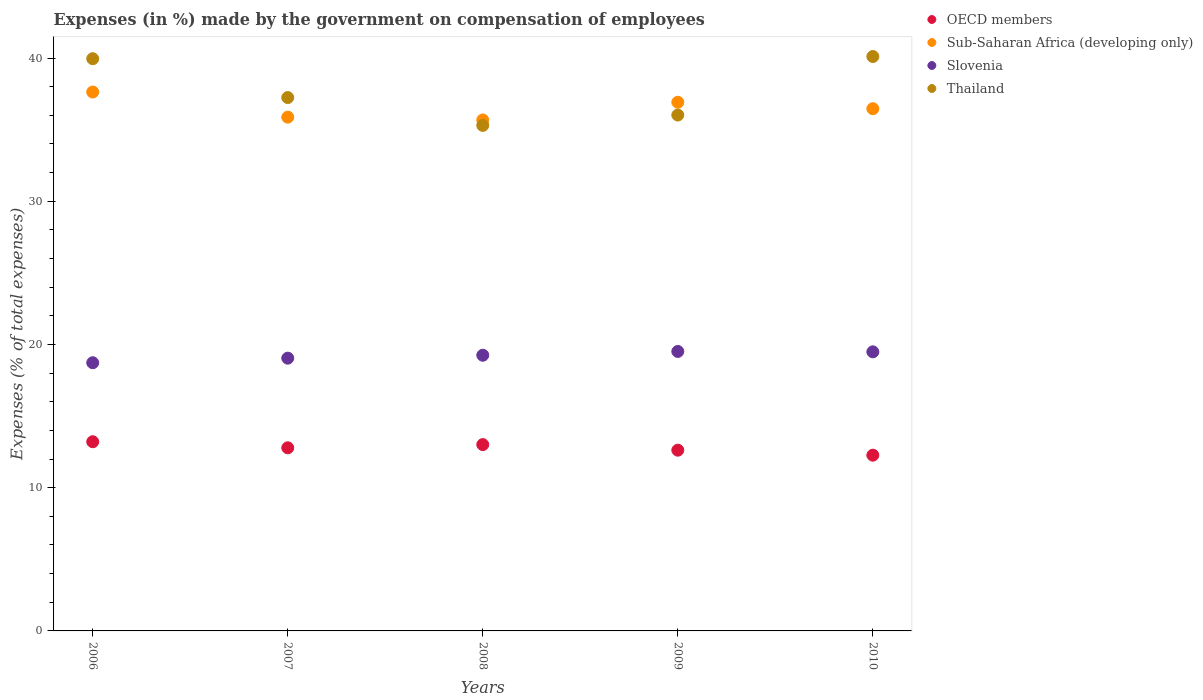Is the number of dotlines equal to the number of legend labels?
Make the answer very short. Yes. What is the percentage of expenses made by the government on compensation of employees in Sub-Saharan Africa (developing only) in 2006?
Give a very brief answer. 37.63. Across all years, what is the maximum percentage of expenses made by the government on compensation of employees in Thailand?
Your answer should be very brief. 40.11. Across all years, what is the minimum percentage of expenses made by the government on compensation of employees in Slovenia?
Give a very brief answer. 18.73. What is the total percentage of expenses made by the government on compensation of employees in OECD members in the graph?
Keep it short and to the point. 63.9. What is the difference between the percentage of expenses made by the government on compensation of employees in Sub-Saharan Africa (developing only) in 2006 and that in 2008?
Ensure brevity in your answer.  1.95. What is the difference between the percentage of expenses made by the government on compensation of employees in OECD members in 2007 and the percentage of expenses made by the government on compensation of employees in Sub-Saharan Africa (developing only) in 2009?
Offer a terse response. -24.13. What is the average percentage of expenses made by the government on compensation of employees in Thailand per year?
Your answer should be very brief. 37.72. In the year 2008, what is the difference between the percentage of expenses made by the government on compensation of employees in Sub-Saharan Africa (developing only) and percentage of expenses made by the government on compensation of employees in OECD members?
Give a very brief answer. 22.67. In how many years, is the percentage of expenses made by the government on compensation of employees in Thailand greater than 26 %?
Offer a very short reply. 5. What is the ratio of the percentage of expenses made by the government on compensation of employees in Slovenia in 2006 to that in 2008?
Your answer should be very brief. 0.97. Is the percentage of expenses made by the government on compensation of employees in Sub-Saharan Africa (developing only) in 2008 less than that in 2010?
Provide a short and direct response. Yes. Is the difference between the percentage of expenses made by the government on compensation of employees in Sub-Saharan Africa (developing only) in 2006 and 2010 greater than the difference between the percentage of expenses made by the government on compensation of employees in OECD members in 2006 and 2010?
Offer a terse response. Yes. What is the difference between the highest and the second highest percentage of expenses made by the government on compensation of employees in Thailand?
Offer a terse response. 0.15. What is the difference between the highest and the lowest percentage of expenses made by the government on compensation of employees in Sub-Saharan Africa (developing only)?
Offer a terse response. 1.95. In how many years, is the percentage of expenses made by the government on compensation of employees in Thailand greater than the average percentage of expenses made by the government on compensation of employees in Thailand taken over all years?
Provide a short and direct response. 2. Is it the case that in every year, the sum of the percentage of expenses made by the government on compensation of employees in Slovenia and percentage of expenses made by the government on compensation of employees in Sub-Saharan Africa (developing only)  is greater than the sum of percentage of expenses made by the government on compensation of employees in Thailand and percentage of expenses made by the government on compensation of employees in OECD members?
Keep it short and to the point. Yes. Is it the case that in every year, the sum of the percentage of expenses made by the government on compensation of employees in Sub-Saharan Africa (developing only) and percentage of expenses made by the government on compensation of employees in OECD members  is greater than the percentage of expenses made by the government on compensation of employees in Thailand?
Your response must be concise. Yes. Does the percentage of expenses made by the government on compensation of employees in OECD members monotonically increase over the years?
Your answer should be compact. No. Is the percentage of expenses made by the government on compensation of employees in Slovenia strictly less than the percentage of expenses made by the government on compensation of employees in Sub-Saharan Africa (developing only) over the years?
Your answer should be very brief. Yes. Are the values on the major ticks of Y-axis written in scientific E-notation?
Provide a short and direct response. No. Does the graph contain any zero values?
Your answer should be very brief. No. Where does the legend appear in the graph?
Provide a short and direct response. Top right. How many legend labels are there?
Give a very brief answer. 4. How are the legend labels stacked?
Give a very brief answer. Vertical. What is the title of the graph?
Your answer should be very brief. Expenses (in %) made by the government on compensation of employees. Does "Syrian Arab Republic" appear as one of the legend labels in the graph?
Your answer should be very brief. No. What is the label or title of the Y-axis?
Ensure brevity in your answer.  Expenses (% of total expenses). What is the Expenses (% of total expenses) of OECD members in 2006?
Provide a succinct answer. 13.21. What is the Expenses (% of total expenses) in Sub-Saharan Africa (developing only) in 2006?
Your answer should be compact. 37.63. What is the Expenses (% of total expenses) of Slovenia in 2006?
Provide a succinct answer. 18.73. What is the Expenses (% of total expenses) in Thailand in 2006?
Make the answer very short. 39.95. What is the Expenses (% of total expenses) in OECD members in 2007?
Offer a terse response. 12.79. What is the Expenses (% of total expenses) in Sub-Saharan Africa (developing only) in 2007?
Give a very brief answer. 35.87. What is the Expenses (% of total expenses) of Slovenia in 2007?
Keep it short and to the point. 19.05. What is the Expenses (% of total expenses) of Thailand in 2007?
Make the answer very short. 37.24. What is the Expenses (% of total expenses) of OECD members in 2008?
Make the answer very short. 13.01. What is the Expenses (% of total expenses) in Sub-Saharan Africa (developing only) in 2008?
Your response must be concise. 35.68. What is the Expenses (% of total expenses) in Slovenia in 2008?
Your answer should be very brief. 19.25. What is the Expenses (% of total expenses) in Thailand in 2008?
Your answer should be compact. 35.3. What is the Expenses (% of total expenses) in OECD members in 2009?
Ensure brevity in your answer.  12.62. What is the Expenses (% of total expenses) in Sub-Saharan Africa (developing only) in 2009?
Offer a very short reply. 36.91. What is the Expenses (% of total expenses) of Slovenia in 2009?
Make the answer very short. 19.51. What is the Expenses (% of total expenses) in Thailand in 2009?
Your answer should be very brief. 36.02. What is the Expenses (% of total expenses) of OECD members in 2010?
Provide a succinct answer. 12.27. What is the Expenses (% of total expenses) of Sub-Saharan Africa (developing only) in 2010?
Ensure brevity in your answer.  36.46. What is the Expenses (% of total expenses) of Slovenia in 2010?
Ensure brevity in your answer.  19.49. What is the Expenses (% of total expenses) in Thailand in 2010?
Make the answer very short. 40.11. Across all years, what is the maximum Expenses (% of total expenses) in OECD members?
Offer a very short reply. 13.21. Across all years, what is the maximum Expenses (% of total expenses) of Sub-Saharan Africa (developing only)?
Your answer should be compact. 37.63. Across all years, what is the maximum Expenses (% of total expenses) in Slovenia?
Make the answer very short. 19.51. Across all years, what is the maximum Expenses (% of total expenses) in Thailand?
Your answer should be very brief. 40.11. Across all years, what is the minimum Expenses (% of total expenses) of OECD members?
Your answer should be compact. 12.27. Across all years, what is the minimum Expenses (% of total expenses) in Sub-Saharan Africa (developing only)?
Ensure brevity in your answer.  35.68. Across all years, what is the minimum Expenses (% of total expenses) in Slovenia?
Offer a terse response. 18.73. Across all years, what is the minimum Expenses (% of total expenses) of Thailand?
Give a very brief answer. 35.3. What is the total Expenses (% of total expenses) in OECD members in the graph?
Offer a terse response. 63.9. What is the total Expenses (% of total expenses) of Sub-Saharan Africa (developing only) in the graph?
Offer a terse response. 182.56. What is the total Expenses (% of total expenses) of Slovenia in the graph?
Keep it short and to the point. 96.02. What is the total Expenses (% of total expenses) of Thailand in the graph?
Your response must be concise. 188.62. What is the difference between the Expenses (% of total expenses) in OECD members in 2006 and that in 2007?
Your response must be concise. 0.42. What is the difference between the Expenses (% of total expenses) of Sub-Saharan Africa (developing only) in 2006 and that in 2007?
Your answer should be compact. 1.75. What is the difference between the Expenses (% of total expenses) in Slovenia in 2006 and that in 2007?
Your answer should be compact. -0.32. What is the difference between the Expenses (% of total expenses) of Thailand in 2006 and that in 2007?
Give a very brief answer. 2.71. What is the difference between the Expenses (% of total expenses) in OECD members in 2006 and that in 2008?
Give a very brief answer. 0.2. What is the difference between the Expenses (% of total expenses) of Sub-Saharan Africa (developing only) in 2006 and that in 2008?
Offer a very short reply. 1.95. What is the difference between the Expenses (% of total expenses) in Slovenia in 2006 and that in 2008?
Offer a very short reply. -0.52. What is the difference between the Expenses (% of total expenses) of Thailand in 2006 and that in 2008?
Provide a succinct answer. 4.66. What is the difference between the Expenses (% of total expenses) of OECD members in 2006 and that in 2009?
Keep it short and to the point. 0.59. What is the difference between the Expenses (% of total expenses) in Sub-Saharan Africa (developing only) in 2006 and that in 2009?
Provide a succinct answer. 0.71. What is the difference between the Expenses (% of total expenses) in Slovenia in 2006 and that in 2009?
Ensure brevity in your answer.  -0.79. What is the difference between the Expenses (% of total expenses) in Thailand in 2006 and that in 2009?
Your answer should be very brief. 3.93. What is the difference between the Expenses (% of total expenses) of OECD members in 2006 and that in 2010?
Offer a very short reply. 0.94. What is the difference between the Expenses (% of total expenses) of Sub-Saharan Africa (developing only) in 2006 and that in 2010?
Provide a short and direct response. 1.16. What is the difference between the Expenses (% of total expenses) in Slovenia in 2006 and that in 2010?
Provide a succinct answer. -0.76. What is the difference between the Expenses (% of total expenses) of Thailand in 2006 and that in 2010?
Your response must be concise. -0.15. What is the difference between the Expenses (% of total expenses) in OECD members in 2007 and that in 2008?
Keep it short and to the point. -0.22. What is the difference between the Expenses (% of total expenses) in Sub-Saharan Africa (developing only) in 2007 and that in 2008?
Keep it short and to the point. 0.2. What is the difference between the Expenses (% of total expenses) in Slovenia in 2007 and that in 2008?
Your answer should be compact. -0.2. What is the difference between the Expenses (% of total expenses) in Thailand in 2007 and that in 2008?
Give a very brief answer. 1.94. What is the difference between the Expenses (% of total expenses) of OECD members in 2007 and that in 2009?
Provide a short and direct response. 0.17. What is the difference between the Expenses (% of total expenses) in Sub-Saharan Africa (developing only) in 2007 and that in 2009?
Keep it short and to the point. -1.04. What is the difference between the Expenses (% of total expenses) in Slovenia in 2007 and that in 2009?
Offer a terse response. -0.47. What is the difference between the Expenses (% of total expenses) in Thailand in 2007 and that in 2009?
Your answer should be very brief. 1.22. What is the difference between the Expenses (% of total expenses) of OECD members in 2007 and that in 2010?
Make the answer very short. 0.52. What is the difference between the Expenses (% of total expenses) in Sub-Saharan Africa (developing only) in 2007 and that in 2010?
Keep it short and to the point. -0.59. What is the difference between the Expenses (% of total expenses) of Slovenia in 2007 and that in 2010?
Your answer should be very brief. -0.44. What is the difference between the Expenses (% of total expenses) in Thailand in 2007 and that in 2010?
Make the answer very short. -2.87. What is the difference between the Expenses (% of total expenses) of OECD members in 2008 and that in 2009?
Offer a terse response. 0.39. What is the difference between the Expenses (% of total expenses) in Sub-Saharan Africa (developing only) in 2008 and that in 2009?
Give a very brief answer. -1.24. What is the difference between the Expenses (% of total expenses) in Slovenia in 2008 and that in 2009?
Your response must be concise. -0.26. What is the difference between the Expenses (% of total expenses) of Thailand in 2008 and that in 2009?
Your answer should be very brief. -0.72. What is the difference between the Expenses (% of total expenses) in OECD members in 2008 and that in 2010?
Offer a very short reply. 0.74. What is the difference between the Expenses (% of total expenses) of Sub-Saharan Africa (developing only) in 2008 and that in 2010?
Your answer should be compact. -0.79. What is the difference between the Expenses (% of total expenses) in Slovenia in 2008 and that in 2010?
Your response must be concise. -0.24. What is the difference between the Expenses (% of total expenses) in Thailand in 2008 and that in 2010?
Keep it short and to the point. -4.81. What is the difference between the Expenses (% of total expenses) of OECD members in 2009 and that in 2010?
Provide a succinct answer. 0.35. What is the difference between the Expenses (% of total expenses) of Sub-Saharan Africa (developing only) in 2009 and that in 2010?
Keep it short and to the point. 0.45. What is the difference between the Expenses (% of total expenses) in Slovenia in 2009 and that in 2010?
Ensure brevity in your answer.  0.03. What is the difference between the Expenses (% of total expenses) in Thailand in 2009 and that in 2010?
Ensure brevity in your answer.  -4.09. What is the difference between the Expenses (% of total expenses) in OECD members in 2006 and the Expenses (% of total expenses) in Sub-Saharan Africa (developing only) in 2007?
Keep it short and to the point. -22.66. What is the difference between the Expenses (% of total expenses) in OECD members in 2006 and the Expenses (% of total expenses) in Slovenia in 2007?
Give a very brief answer. -5.84. What is the difference between the Expenses (% of total expenses) of OECD members in 2006 and the Expenses (% of total expenses) of Thailand in 2007?
Keep it short and to the point. -24.03. What is the difference between the Expenses (% of total expenses) in Sub-Saharan Africa (developing only) in 2006 and the Expenses (% of total expenses) in Slovenia in 2007?
Your answer should be very brief. 18.58. What is the difference between the Expenses (% of total expenses) of Sub-Saharan Africa (developing only) in 2006 and the Expenses (% of total expenses) of Thailand in 2007?
Offer a terse response. 0.39. What is the difference between the Expenses (% of total expenses) of Slovenia in 2006 and the Expenses (% of total expenses) of Thailand in 2007?
Keep it short and to the point. -18.52. What is the difference between the Expenses (% of total expenses) in OECD members in 2006 and the Expenses (% of total expenses) in Sub-Saharan Africa (developing only) in 2008?
Offer a terse response. -22.47. What is the difference between the Expenses (% of total expenses) of OECD members in 2006 and the Expenses (% of total expenses) of Slovenia in 2008?
Give a very brief answer. -6.04. What is the difference between the Expenses (% of total expenses) in OECD members in 2006 and the Expenses (% of total expenses) in Thailand in 2008?
Provide a succinct answer. -22.09. What is the difference between the Expenses (% of total expenses) of Sub-Saharan Africa (developing only) in 2006 and the Expenses (% of total expenses) of Slovenia in 2008?
Provide a short and direct response. 18.38. What is the difference between the Expenses (% of total expenses) of Sub-Saharan Africa (developing only) in 2006 and the Expenses (% of total expenses) of Thailand in 2008?
Your response must be concise. 2.33. What is the difference between the Expenses (% of total expenses) in Slovenia in 2006 and the Expenses (% of total expenses) in Thailand in 2008?
Provide a succinct answer. -16.57. What is the difference between the Expenses (% of total expenses) of OECD members in 2006 and the Expenses (% of total expenses) of Sub-Saharan Africa (developing only) in 2009?
Provide a succinct answer. -23.71. What is the difference between the Expenses (% of total expenses) of OECD members in 2006 and the Expenses (% of total expenses) of Slovenia in 2009?
Offer a terse response. -6.31. What is the difference between the Expenses (% of total expenses) of OECD members in 2006 and the Expenses (% of total expenses) of Thailand in 2009?
Give a very brief answer. -22.81. What is the difference between the Expenses (% of total expenses) in Sub-Saharan Africa (developing only) in 2006 and the Expenses (% of total expenses) in Slovenia in 2009?
Ensure brevity in your answer.  18.11. What is the difference between the Expenses (% of total expenses) of Sub-Saharan Africa (developing only) in 2006 and the Expenses (% of total expenses) of Thailand in 2009?
Provide a short and direct response. 1.61. What is the difference between the Expenses (% of total expenses) in Slovenia in 2006 and the Expenses (% of total expenses) in Thailand in 2009?
Offer a terse response. -17.29. What is the difference between the Expenses (% of total expenses) in OECD members in 2006 and the Expenses (% of total expenses) in Sub-Saharan Africa (developing only) in 2010?
Ensure brevity in your answer.  -23.26. What is the difference between the Expenses (% of total expenses) of OECD members in 2006 and the Expenses (% of total expenses) of Slovenia in 2010?
Provide a succinct answer. -6.28. What is the difference between the Expenses (% of total expenses) of OECD members in 2006 and the Expenses (% of total expenses) of Thailand in 2010?
Make the answer very short. -26.9. What is the difference between the Expenses (% of total expenses) of Sub-Saharan Africa (developing only) in 2006 and the Expenses (% of total expenses) of Slovenia in 2010?
Your answer should be very brief. 18.14. What is the difference between the Expenses (% of total expenses) in Sub-Saharan Africa (developing only) in 2006 and the Expenses (% of total expenses) in Thailand in 2010?
Your response must be concise. -2.48. What is the difference between the Expenses (% of total expenses) of Slovenia in 2006 and the Expenses (% of total expenses) of Thailand in 2010?
Offer a very short reply. -21.38. What is the difference between the Expenses (% of total expenses) in OECD members in 2007 and the Expenses (% of total expenses) in Sub-Saharan Africa (developing only) in 2008?
Provide a succinct answer. -22.89. What is the difference between the Expenses (% of total expenses) in OECD members in 2007 and the Expenses (% of total expenses) in Slovenia in 2008?
Ensure brevity in your answer.  -6.46. What is the difference between the Expenses (% of total expenses) of OECD members in 2007 and the Expenses (% of total expenses) of Thailand in 2008?
Provide a succinct answer. -22.51. What is the difference between the Expenses (% of total expenses) of Sub-Saharan Africa (developing only) in 2007 and the Expenses (% of total expenses) of Slovenia in 2008?
Keep it short and to the point. 16.62. What is the difference between the Expenses (% of total expenses) in Sub-Saharan Africa (developing only) in 2007 and the Expenses (% of total expenses) in Thailand in 2008?
Keep it short and to the point. 0.58. What is the difference between the Expenses (% of total expenses) in Slovenia in 2007 and the Expenses (% of total expenses) in Thailand in 2008?
Give a very brief answer. -16.25. What is the difference between the Expenses (% of total expenses) of OECD members in 2007 and the Expenses (% of total expenses) of Sub-Saharan Africa (developing only) in 2009?
Keep it short and to the point. -24.13. What is the difference between the Expenses (% of total expenses) in OECD members in 2007 and the Expenses (% of total expenses) in Slovenia in 2009?
Provide a succinct answer. -6.73. What is the difference between the Expenses (% of total expenses) in OECD members in 2007 and the Expenses (% of total expenses) in Thailand in 2009?
Offer a terse response. -23.23. What is the difference between the Expenses (% of total expenses) of Sub-Saharan Africa (developing only) in 2007 and the Expenses (% of total expenses) of Slovenia in 2009?
Offer a very short reply. 16.36. What is the difference between the Expenses (% of total expenses) of Sub-Saharan Africa (developing only) in 2007 and the Expenses (% of total expenses) of Thailand in 2009?
Offer a terse response. -0.15. What is the difference between the Expenses (% of total expenses) in Slovenia in 2007 and the Expenses (% of total expenses) in Thailand in 2009?
Your response must be concise. -16.98. What is the difference between the Expenses (% of total expenses) of OECD members in 2007 and the Expenses (% of total expenses) of Sub-Saharan Africa (developing only) in 2010?
Offer a terse response. -23.68. What is the difference between the Expenses (% of total expenses) of OECD members in 2007 and the Expenses (% of total expenses) of Slovenia in 2010?
Make the answer very short. -6.7. What is the difference between the Expenses (% of total expenses) of OECD members in 2007 and the Expenses (% of total expenses) of Thailand in 2010?
Provide a short and direct response. -27.32. What is the difference between the Expenses (% of total expenses) of Sub-Saharan Africa (developing only) in 2007 and the Expenses (% of total expenses) of Slovenia in 2010?
Your answer should be very brief. 16.39. What is the difference between the Expenses (% of total expenses) in Sub-Saharan Africa (developing only) in 2007 and the Expenses (% of total expenses) in Thailand in 2010?
Provide a succinct answer. -4.24. What is the difference between the Expenses (% of total expenses) of Slovenia in 2007 and the Expenses (% of total expenses) of Thailand in 2010?
Provide a succinct answer. -21.06. What is the difference between the Expenses (% of total expenses) in OECD members in 2008 and the Expenses (% of total expenses) in Sub-Saharan Africa (developing only) in 2009?
Make the answer very short. -23.9. What is the difference between the Expenses (% of total expenses) of OECD members in 2008 and the Expenses (% of total expenses) of Slovenia in 2009?
Your answer should be very brief. -6.5. What is the difference between the Expenses (% of total expenses) of OECD members in 2008 and the Expenses (% of total expenses) of Thailand in 2009?
Keep it short and to the point. -23.01. What is the difference between the Expenses (% of total expenses) of Sub-Saharan Africa (developing only) in 2008 and the Expenses (% of total expenses) of Slovenia in 2009?
Offer a very short reply. 16.16. What is the difference between the Expenses (% of total expenses) in Sub-Saharan Africa (developing only) in 2008 and the Expenses (% of total expenses) in Thailand in 2009?
Ensure brevity in your answer.  -0.34. What is the difference between the Expenses (% of total expenses) of Slovenia in 2008 and the Expenses (% of total expenses) of Thailand in 2009?
Provide a succinct answer. -16.77. What is the difference between the Expenses (% of total expenses) of OECD members in 2008 and the Expenses (% of total expenses) of Sub-Saharan Africa (developing only) in 2010?
Keep it short and to the point. -23.45. What is the difference between the Expenses (% of total expenses) of OECD members in 2008 and the Expenses (% of total expenses) of Slovenia in 2010?
Offer a terse response. -6.48. What is the difference between the Expenses (% of total expenses) in OECD members in 2008 and the Expenses (% of total expenses) in Thailand in 2010?
Your answer should be very brief. -27.1. What is the difference between the Expenses (% of total expenses) of Sub-Saharan Africa (developing only) in 2008 and the Expenses (% of total expenses) of Slovenia in 2010?
Keep it short and to the point. 16.19. What is the difference between the Expenses (% of total expenses) of Sub-Saharan Africa (developing only) in 2008 and the Expenses (% of total expenses) of Thailand in 2010?
Offer a very short reply. -4.43. What is the difference between the Expenses (% of total expenses) of Slovenia in 2008 and the Expenses (% of total expenses) of Thailand in 2010?
Keep it short and to the point. -20.86. What is the difference between the Expenses (% of total expenses) in OECD members in 2009 and the Expenses (% of total expenses) in Sub-Saharan Africa (developing only) in 2010?
Your answer should be very brief. -23.84. What is the difference between the Expenses (% of total expenses) in OECD members in 2009 and the Expenses (% of total expenses) in Slovenia in 2010?
Offer a terse response. -6.87. What is the difference between the Expenses (% of total expenses) of OECD members in 2009 and the Expenses (% of total expenses) of Thailand in 2010?
Your answer should be very brief. -27.49. What is the difference between the Expenses (% of total expenses) of Sub-Saharan Africa (developing only) in 2009 and the Expenses (% of total expenses) of Slovenia in 2010?
Ensure brevity in your answer.  17.43. What is the difference between the Expenses (% of total expenses) in Sub-Saharan Africa (developing only) in 2009 and the Expenses (% of total expenses) in Thailand in 2010?
Keep it short and to the point. -3.19. What is the difference between the Expenses (% of total expenses) in Slovenia in 2009 and the Expenses (% of total expenses) in Thailand in 2010?
Keep it short and to the point. -20.59. What is the average Expenses (% of total expenses) in OECD members per year?
Make the answer very short. 12.78. What is the average Expenses (% of total expenses) in Sub-Saharan Africa (developing only) per year?
Your answer should be very brief. 36.51. What is the average Expenses (% of total expenses) of Slovenia per year?
Ensure brevity in your answer.  19.2. What is the average Expenses (% of total expenses) of Thailand per year?
Keep it short and to the point. 37.72. In the year 2006, what is the difference between the Expenses (% of total expenses) of OECD members and Expenses (% of total expenses) of Sub-Saharan Africa (developing only)?
Offer a very short reply. -24.42. In the year 2006, what is the difference between the Expenses (% of total expenses) in OECD members and Expenses (% of total expenses) in Slovenia?
Ensure brevity in your answer.  -5.52. In the year 2006, what is the difference between the Expenses (% of total expenses) in OECD members and Expenses (% of total expenses) in Thailand?
Give a very brief answer. -26.75. In the year 2006, what is the difference between the Expenses (% of total expenses) of Sub-Saharan Africa (developing only) and Expenses (% of total expenses) of Slovenia?
Make the answer very short. 18.9. In the year 2006, what is the difference between the Expenses (% of total expenses) in Sub-Saharan Africa (developing only) and Expenses (% of total expenses) in Thailand?
Provide a succinct answer. -2.33. In the year 2006, what is the difference between the Expenses (% of total expenses) of Slovenia and Expenses (% of total expenses) of Thailand?
Keep it short and to the point. -21.23. In the year 2007, what is the difference between the Expenses (% of total expenses) in OECD members and Expenses (% of total expenses) in Sub-Saharan Africa (developing only)?
Your answer should be compact. -23.09. In the year 2007, what is the difference between the Expenses (% of total expenses) in OECD members and Expenses (% of total expenses) in Slovenia?
Provide a short and direct response. -6.26. In the year 2007, what is the difference between the Expenses (% of total expenses) of OECD members and Expenses (% of total expenses) of Thailand?
Give a very brief answer. -24.46. In the year 2007, what is the difference between the Expenses (% of total expenses) in Sub-Saharan Africa (developing only) and Expenses (% of total expenses) in Slovenia?
Your answer should be compact. 16.83. In the year 2007, what is the difference between the Expenses (% of total expenses) in Sub-Saharan Africa (developing only) and Expenses (% of total expenses) in Thailand?
Offer a terse response. -1.37. In the year 2007, what is the difference between the Expenses (% of total expenses) in Slovenia and Expenses (% of total expenses) in Thailand?
Make the answer very short. -18.2. In the year 2008, what is the difference between the Expenses (% of total expenses) in OECD members and Expenses (% of total expenses) in Sub-Saharan Africa (developing only)?
Your answer should be compact. -22.67. In the year 2008, what is the difference between the Expenses (% of total expenses) in OECD members and Expenses (% of total expenses) in Slovenia?
Make the answer very short. -6.24. In the year 2008, what is the difference between the Expenses (% of total expenses) in OECD members and Expenses (% of total expenses) in Thailand?
Your response must be concise. -22.29. In the year 2008, what is the difference between the Expenses (% of total expenses) in Sub-Saharan Africa (developing only) and Expenses (% of total expenses) in Slovenia?
Your response must be concise. 16.43. In the year 2008, what is the difference between the Expenses (% of total expenses) in Sub-Saharan Africa (developing only) and Expenses (% of total expenses) in Thailand?
Give a very brief answer. 0.38. In the year 2008, what is the difference between the Expenses (% of total expenses) in Slovenia and Expenses (% of total expenses) in Thailand?
Offer a very short reply. -16.05. In the year 2009, what is the difference between the Expenses (% of total expenses) of OECD members and Expenses (% of total expenses) of Sub-Saharan Africa (developing only)?
Your answer should be compact. -24.29. In the year 2009, what is the difference between the Expenses (% of total expenses) of OECD members and Expenses (% of total expenses) of Slovenia?
Provide a short and direct response. -6.89. In the year 2009, what is the difference between the Expenses (% of total expenses) of OECD members and Expenses (% of total expenses) of Thailand?
Keep it short and to the point. -23.4. In the year 2009, what is the difference between the Expenses (% of total expenses) in Sub-Saharan Africa (developing only) and Expenses (% of total expenses) in Slovenia?
Make the answer very short. 17.4. In the year 2009, what is the difference between the Expenses (% of total expenses) of Sub-Saharan Africa (developing only) and Expenses (% of total expenses) of Thailand?
Offer a very short reply. 0.89. In the year 2009, what is the difference between the Expenses (% of total expenses) of Slovenia and Expenses (% of total expenses) of Thailand?
Keep it short and to the point. -16.51. In the year 2010, what is the difference between the Expenses (% of total expenses) in OECD members and Expenses (% of total expenses) in Sub-Saharan Africa (developing only)?
Your response must be concise. -24.19. In the year 2010, what is the difference between the Expenses (% of total expenses) of OECD members and Expenses (% of total expenses) of Slovenia?
Keep it short and to the point. -7.22. In the year 2010, what is the difference between the Expenses (% of total expenses) in OECD members and Expenses (% of total expenses) in Thailand?
Give a very brief answer. -27.84. In the year 2010, what is the difference between the Expenses (% of total expenses) in Sub-Saharan Africa (developing only) and Expenses (% of total expenses) in Slovenia?
Provide a succinct answer. 16.98. In the year 2010, what is the difference between the Expenses (% of total expenses) in Sub-Saharan Africa (developing only) and Expenses (% of total expenses) in Thailand?
Make the answer very short. -3.64. In the year 2010, what is the difference between the Expenses (% of total expenses) of Slovenia and Expenses (% of total expenses) of Thailand?
Give a very brief answer. -20.62. What is the ratio of the Expenses (% of total expenses) in OECD members in 2006 to that in 2007?
Your answer should be compact. 1.03. What is the ratio of the Expenses (% of total expenses) of Sub-Saharan Africa (developing only) in 2006 to that in 2007?
Your response must be concise. 1.05. What is the ratio of the Expenses (% of total expenses) of Slovenia in 2006 to that in 2007?
Give a very brief answer. 0.98. What is the ratio of the Expenses (% of total expenses) of Thailand in 2006 to that in 2007?
Keep it short and to the point. 1.07. What is the ratio of the Expenses (% of total expenses) in OECD members in 2006 to that in 2008?
Ensure brevity in your answer.  1.02. What is the ratio of the Expenses (% of total expenses) in Sub-Saharan Africa (developing only) in 2006 to that in 2008?
Give a very brief answer. 1.05. What is the ratio of the Expenses (% of total expenses) in Slovenia in 2006 to that in 2008?
Provide a short and direct response. 0.97. What is the ratio of the Expenses (% of total expenses) in Thailand in 2006 to that in 2008?
Your response must be concise. 1.13. What is the ratio of the Expenses (% of total expenses) in OECD members in 2006 to that in 2009?
Offer a terse response. 1.05. What is the ratio of the Expenses (% of total expenses) of Sub-Saharan Africa (developing only) in 2006 to that in 2009?
Your answer should be very brief. 1.02. What is the ratio of the Expenses (% of total expenses) of Slovenia in 2006 to that in 2009?
Your answer should be compact. 0.96. What is the ratio of the Expenses (% of total expenses) in Thailand in 2006 to that in 2009?
Keep it short and to the point. 1.11. What is the ratio of the Expenses (% of total expenses) in OECD members in 2006 to that in 2010?
Ensure brevity in your answer.  1.08. What is the ratio of the Expenses (% of total expenses) of Sub-Saharan Africa (developing only) in 2006 to that in 2010?
Your answer should be compact. 1.03. What is the ratio of the Expenses (% of total expenses) in Thailand in 2006 to that in 2010?
Provide a short and direct response. 1. What is the ratio of the Expenses (% of total expenses) in OECD members in 2007 to that in 2008?
Your answer should be very brief. 0.98. What is the ratio of the Expenses (% of total expenses) in Sub-Saharan Africa (developing only) in 2007 to that in 2008?
Ensure brevity in your answer.  1.01. What is the ratio of the Expenses (% of total expenses) in Slovenia in 2007 to that in 2008?
Give a very brief answer. 0.99. What is the ratio of the Expenses (% of total expenses) in Thailand in 2007 to that in 2008?
Your answer should be compact. 1.06. What is the ratio of the Expenses (% of total expenses) in OECD members in 2007 to that in 2009?
Your answer should be very brief. 1.01. What is the ratio of the Expenses (% of total expenses) of Sub-Saharan Africa (developing only) in 2007 to that in 2009?
Provide a succinct answer. 0.97. What is the ratio of the Expenses (% of total expenses) in Thailand in 2007 to that in 2009?
Your answer should be very brief. 1.03. What is the ratio of the Expenses (% of total expenses) of OECD members in 2007 to that in 2010?
Offer a terse response. 1.04. What is the ratio of the Expenses (% of total expenses) in Sub-Saharan Africa (developing only) in 2007 to that in 2010?
Offer a very short reply. 0.98. What is the ratio of the Expenses (% of total expenses) of Slovenia in 2007 to that in 2010?
Offer a terse response. 0.98. What is the ratio of the Expenses (% of total expenses) in Thailand in 2007 to that in 2010?
Offer a terse response. 0.93. What is the ratio of the Expenses (% of total expenses) of OECD members in 2008 to that in 2009?
Your answer should be very brief. 1.03. What is the ratio of the Expenses (% of total expenses) in Sub-Saharan Africa (developing only) in 2008 to that in 2009?
Offer a very short reply. 0.97. What is the ratio of the Expenses (% of total expenses) of Slovenia in 2008 to that in 2009?
Your response must be concise. 0.99. What is the ratio of the Expenses (% of total expenses) of Thailand in 2008 to that in 2009?
Ensure brevity in your answer.  0.98. What is the ratio of the Expenses (% of total expenses) of OECD members in 2008 to that in 2010?
Give a very brief answer. 1.06. What is the ratio of the Expenses (% of total expenses) of Sub-Saharan Africa (developing only) in 2008 to that in 2010?
Provide a short and direct response. 0.98. What is the ratio of the Expenses (% of total expenses) in Thailand in 2008 to that in 2010?
Keep it short and to the point. 0.88. What is the ratio of the Expenses (% of total expenses) in OECD members in 2009 to that in 2010?
Your answer should be very brief. 1.03. What is the ratio of the Expenses (% of total expenses) in Sub-Saharan Africa (developing only) in 2009 to that in 2010?
Your answer should be very brief. 1.01. What is the ratio of the Expenses (% of total expenses) in Slovenia in 2009 to that in 2010?
Give a very brief answer. 1. What is the ratio of the Expenses (% of total expenses) in Thailand in 2009 to that in 2010?
Offer a very short reply. 0.9. What is the difference between the highest and the second highest Expenses (% of total expenses) of OECD members?
Offer a very short reply. 0.2. What is the difference between the highest and the second highest Expenses (% of total expenses) in Sub-Saharan Africa (developing only)?
Your answer should be very brief. 0.71. What is the difference between the highest and the second highest Expenses (% of total expenses) in Slovenia?
Offer a terse response. 0.03. What is the difference between the highest and the second highest Expenses (% of total expenses) of Thailand?
Provide a short and direct response. 0.15. What is the difference between the highest and the lowest Expenses (% of total expenses) of OECD members?
Provide a short and direct response. 0.94. What is the difference between the highest and the lowest Expenses (% of total expenses) of Sub-Saharan Africa (developing only)?
Keep it short and to the point. 1.95. What is the difference between the highest and the lowest Expenses (% of total expenses) in Slovenia?
Ensure brevity in your answer.  0.79. What is the difference between the highest and the lowest Expenses (% of total expenses) of Thailand?
Your response must be concise. 4.81. 